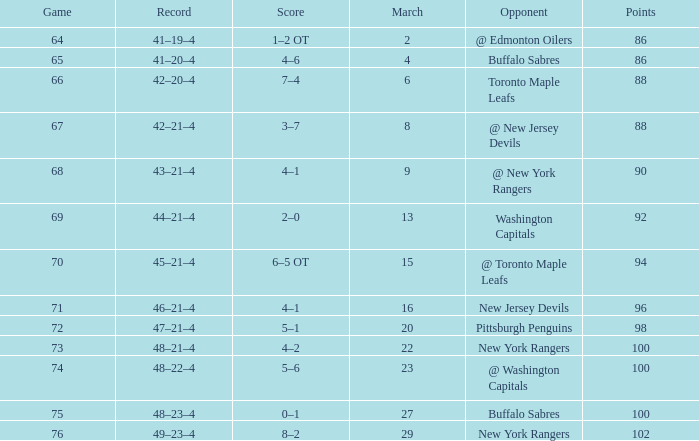Which Score has a March larger than 15, and Points larger than 96, and a Game smaller than 76, and an Opponent of @ washington capitals? 5–6. 